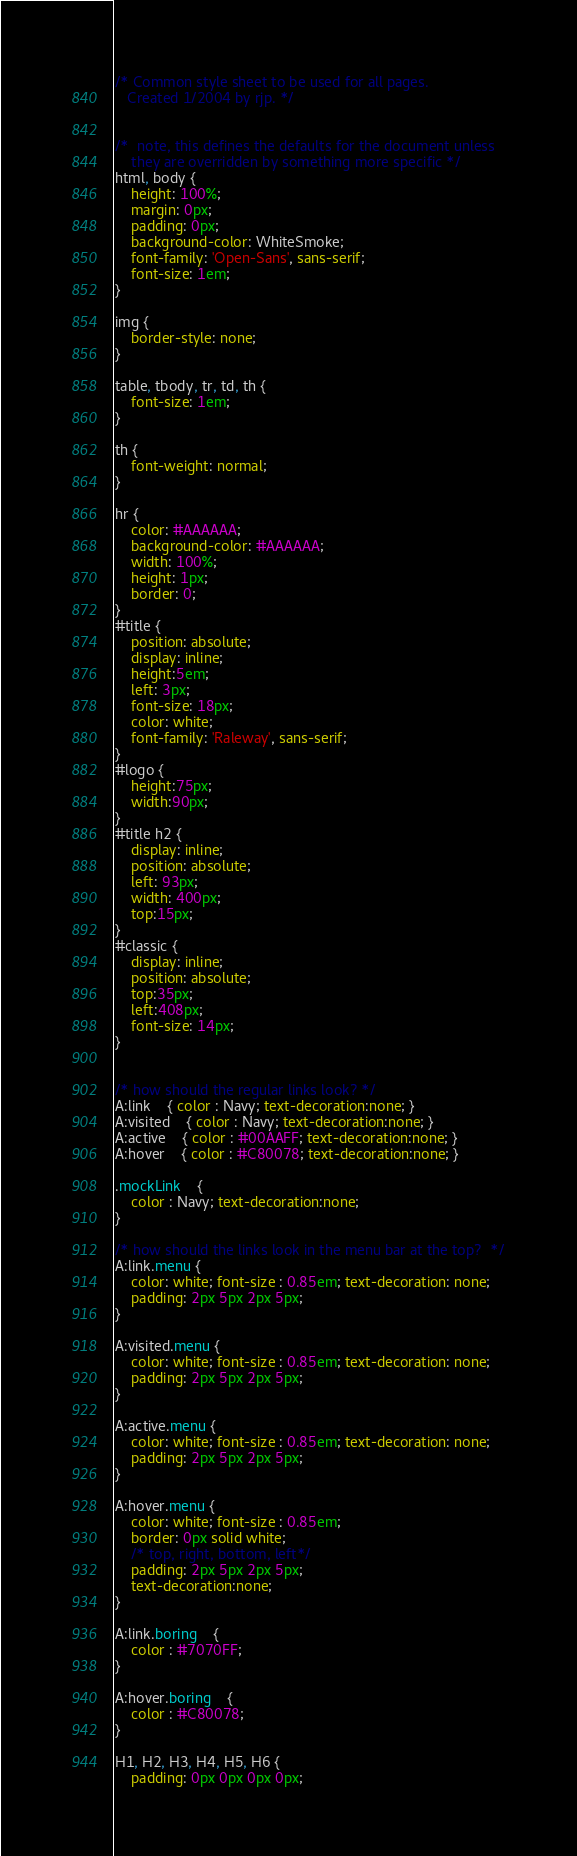<code> <loc_0><loc_0><loc_500><loc_500><_CSS_>/* Common style sheet to be used for all pages. 
   Created 1/2004 by rjp. */

   
/*	note, this defines the defaults for the document unless 
	they are overridden by something more specific */
html, body {
	height: 100%;
	margin: 0px;
	padding: 0px;
	background-color: WhiteSmoke;
	font-family: 'Open-Sans', sans-serif;
	font-size: 1em;
}

img {
	border-style: none;
}

table, tbody, tr, td, th { 
	font-size: 1em;
}

th {
    font-weight: normal;
}

hr { 
    color: #AAAAAA;
    background-color: #AAAAAA;
    width: 100%;
    height: 1px;
    border: 0;
}
#title {
    position: absolute;
    display: inline;
    height:5em;
    left: 3px;
    font-size: 18px;
    color: white;
    font-family: 'Raleway', sans-serif;
}
#logo {
    height:75px;
    width:90px;
}
#title h2 {
    display: inline;
    position: absolute;
    left: 93px;
    width: 400px;
    top:15px;
}
#classic {
    display: inline;
    position: absolute;
    top:35px;
    left:408px;
    font-size: 14px;
}


/* how should the regular links look? */
A:link	{ color : Navy; text-decoration:none; }
A:visited	{ color : Navy; text-decoration:none; }
A:active	{ color : #00AAFF; text-decoration:none; }
A:hover	{ color : #C80078; text-decoration:none; }

.mockLink	{
	color : Navy; text-decoration:none;
}

/* how should the links look in the menu bar at the top?  */
A:link.menu { 
	color: white; font-size : 0.85em; text-decoration: none; 
	padding: 2px 5px 2px 5px;
}

A:visited.menu { 
	color: white; font-size : 0.85em; text-decoration: none; 
	padding: 2px 5px 2px 5px;
}

A:active.menu { 
	color: white; font-size : 0.85em; text-decoration: none; 
	padding: 2px 5px 2px 5px;
}

A:hover.menu { 
	color: white; font-size : 0.85em; 
	border: 0px solid white;
	/* top, right, bottom, left*/
	padding: 2px 5px 2px 5px;
	text-decoration:none; 
}

A:link.boring	{
	color : #7070FF;
}       

A:hover.boring	{
	color : #C80078;
}       

H1, H2, H3, H4, H5, H6 { 
	padding: 0px 0px 0px 0px;</code> 